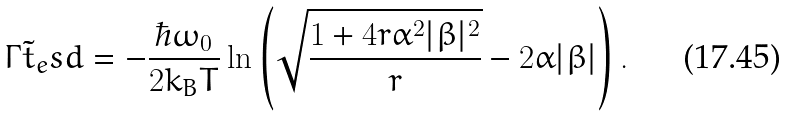<formula> <loc_0><loc_0><loc_500><loc_500>\Gamma \tilde { t } _ { e } s d = - \frac { \hbar { \omega } _ { 0 } } { 2 k _ { B } T } \ln \left ( \sqrt { \frac { 1 + 4 r \alpha ^ { 2 } | \beta | ^ { 2 } } { r } } - 2 \alpha | \beta | \right ) .</formula> 